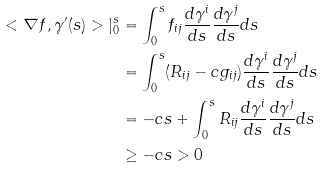Convert formula to latex. <formula><loc_0><loc_0><loc_500><loc_500>< \nabla f , \gamma ^ { \prime } ( s ) > | _ { 0 } ^ { s } & = \int _ { 0 } ^ { s } f _ { i j } \frac { d \gamma ^ { i } } { d s } \frac { d \gamma ^ { j } } { d s } d s \\ & = \int _ { 0 } ^ { s } ( R _ { i j } - c g _ { i j } ) \frac { d \gamma ^ { i } } { d s } \frac { d \gamma ^ { j } } { d s } d s \\ & = - c s + \int _ { 0 } ^ { s } R _ { i j } \frac { d \gamma ^ { i } } { d s } \frac { d \gamma ^ { j } } { d s } d s \\ & \geq - c s > 0</formula> 